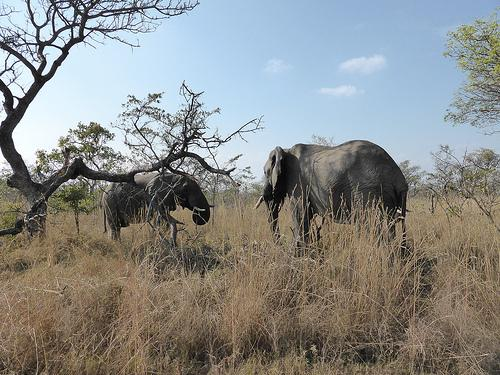What are the elephants doing? The elephants are facing each other in their natural habitat, surrounded by tall grass and trees, under a bright blue sky with white clouds. Name two objects or animals that are interacting with each other in the image. Two elephants are facing each other and seem to be interacting with one another in their natural environment. Analyze the sentiment of the image by describing the overall atmosphere. The image presents a serene and peaceful atmosphere capturing two elephants in their natural habitat, surrounded by trees and tall grass, with a beautiful blue sky and white clouds above. Give two examples of details that stand out about the trees. Some trees have green leaves while others have bare branches, and one tree trunk is very crooked. Count the number of clouds and describe their appearance in the image. There are several instances of puffy white clouds and wispy clouds in the image, making for a total of at least three different cloud formations. Explain the landscape in which the elephants are residing and mention the continent it might belong to. The elephants are in a wide, flat savannah with tall brown grass, thin greenleafed trees, and very dry brush grass, suggesting that they might be in an African savannah. What dominant colors can you see in the image? The dominant colors in this image are blue (sky), green (trees and leaves), brown (dry grass), and gray (elephants). Do both elephants have tusks and if so, how are they different in size? Yes, both elephants have tusks; the larger elephant has longer white tusks, while the smaller elephant has shorter, smaller tusks. Determine if the area where the elephants are appears to be lush or dry. The area appears to be more dry as it has very dry brush grass, long dry grass around the elephants, and a few bare trees. Discuss the weather conditions in the image based on the appearance of the sky. The weather conditions appear to be sunny and clear, with a bright blue sky filled with puffy white clouds and wispy clouds. Identify the regions containing clouds in the sky. X:255 Y:40 Width:140 Height:140; X:320 Y:42 Width:76 Height:76; X:248 Y:13 Width:150 Height:150; X:253 Y:42 Width:138 Height:138 Identify the type of interaction between the two elephants. Friendly and social. Are there any unusual or unexpected objects within the image? No. What type of grass is present in the image? Tall, dry, brown grass. Find any text present in the image. No text present. What color are the trees without leaves? Dark brown or black. What is the sentiment conveyed by this image? Peaceful and calm. Describe the tail of the smaller elephant. Gray and short, X:97 Y:207 Width:10 Height:10. Describe the interaction between the two wild animals. Two elephants are facing each other in their natural habitat. What type of habitat do the elephants seem to be in? Wide flat savanna. Search for the beautiful sunset casting a warm glow over the savannah. It's such a serene scene! No, it's not mentioned in the image. Rate the quality of the image on a scale of 1 to 10. 7. What type of tree is the one with the crooked trunk? Bare tree with dark branches (X:0 Y:42 Width:55 Height:55). Do the two elephants seem to be affectionate or aggressive towards each other? Affectionate. Which of the following objects is not in the image: brown grass, blue water, white tusks? Blue water. What is the color of the tusks on the elephants? White. What kind of animals can be seen in this image? Elephants. Which object is being referred to by "the tree with green leaves"? Thin greenleafed trees (X:425 Y:20 Width:70 Height:70) How many trees with green leaves are there in the image? 3. What is the color of the sky in the image? Blue. 